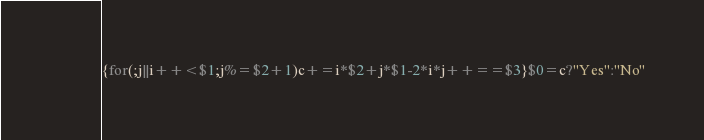Convert code to text. <code><loc_0><loc_0><loc_500><loc_500><_Awk_>{for(;j||i++<$1;j%=$2+1)c+=i*$2+j*$1-2*i*j++==$3}$0=c?"Yes":"No"</code> 